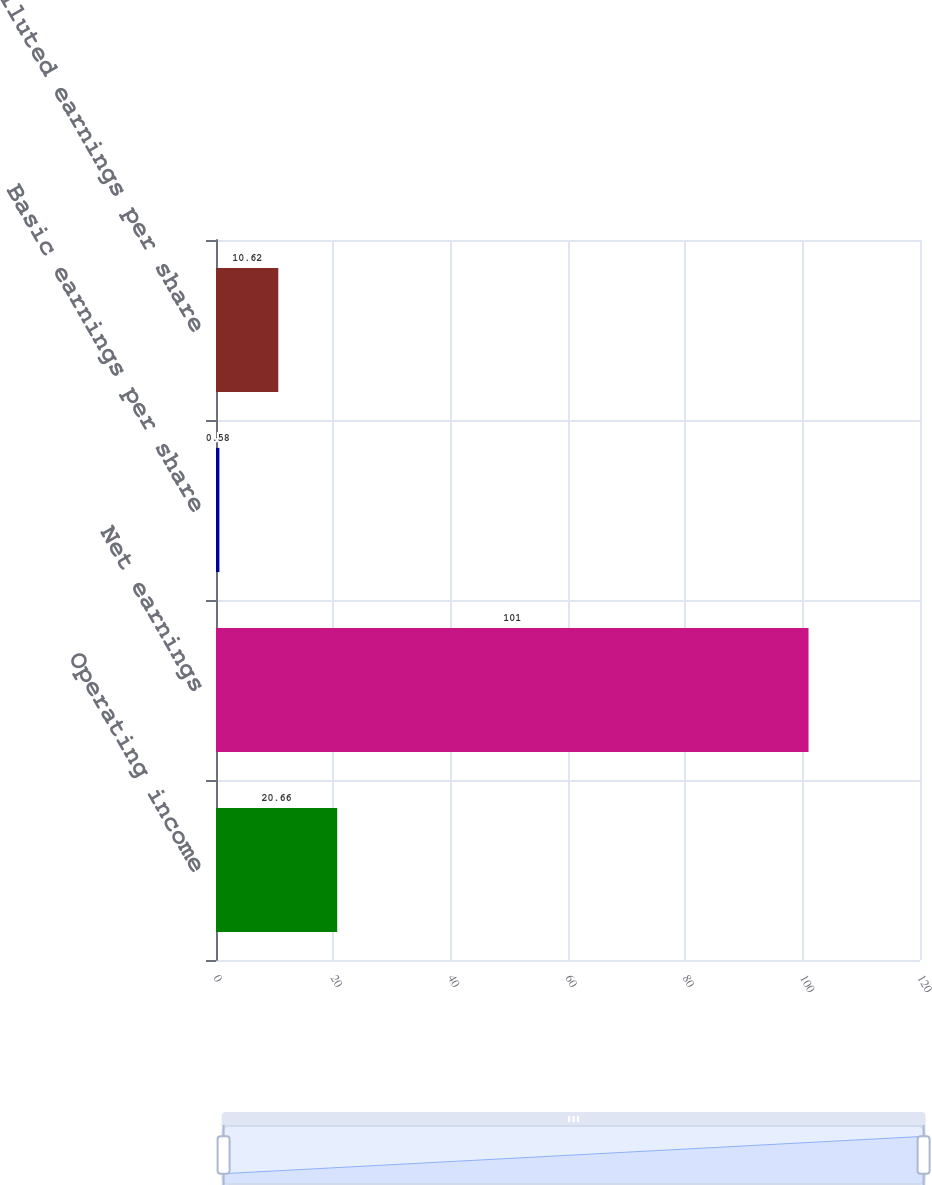<chart> <loc_0><loc_0><loc_500><loc_500><bar_chart><fcel>Operating income<fcel>Net earnings<fcel>Basic earnings per share<fcel>Diluted earnings per share<nl><fcel>20.66<fcel>101<fcel>0.58<fcel>10.62<nl></chart> 